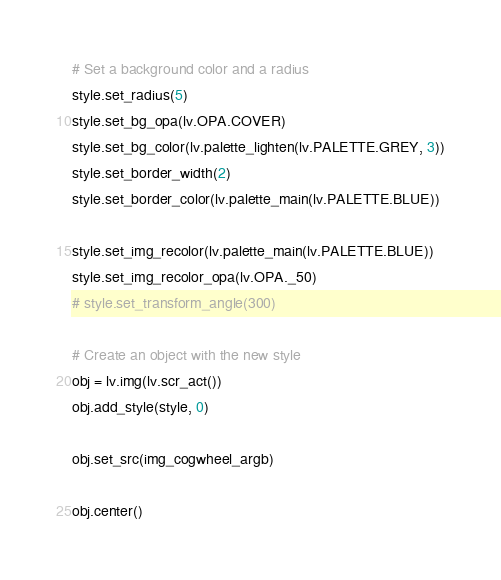<code> <loc_0><loc_0><loc_500><loc_500><_Python_># Set a background color and a radius
style.set_radius(5)
style.set_bg_opa(lv.OPA.COVER)
style.set_bg_color(lv.palette_lighten(lv.PALETTE.GREY, 3))
style.set_border_width(2)
style.set_border_color(lv.palette_main(lv.PALETTE.BLUE))

style.set_img_recolor(lv.palette_main(lv.PALETTE.BLUE))
style.set_img_recolor_opa(lv.OPA._50)
# style.set_transform_angle(300)

# Create an object with the new style
obj = lv.img(lv.scr_act())
obj.add_style(style, 0)

obj.set_src(img_cogwheel_argb)

obj.center()

</code> 